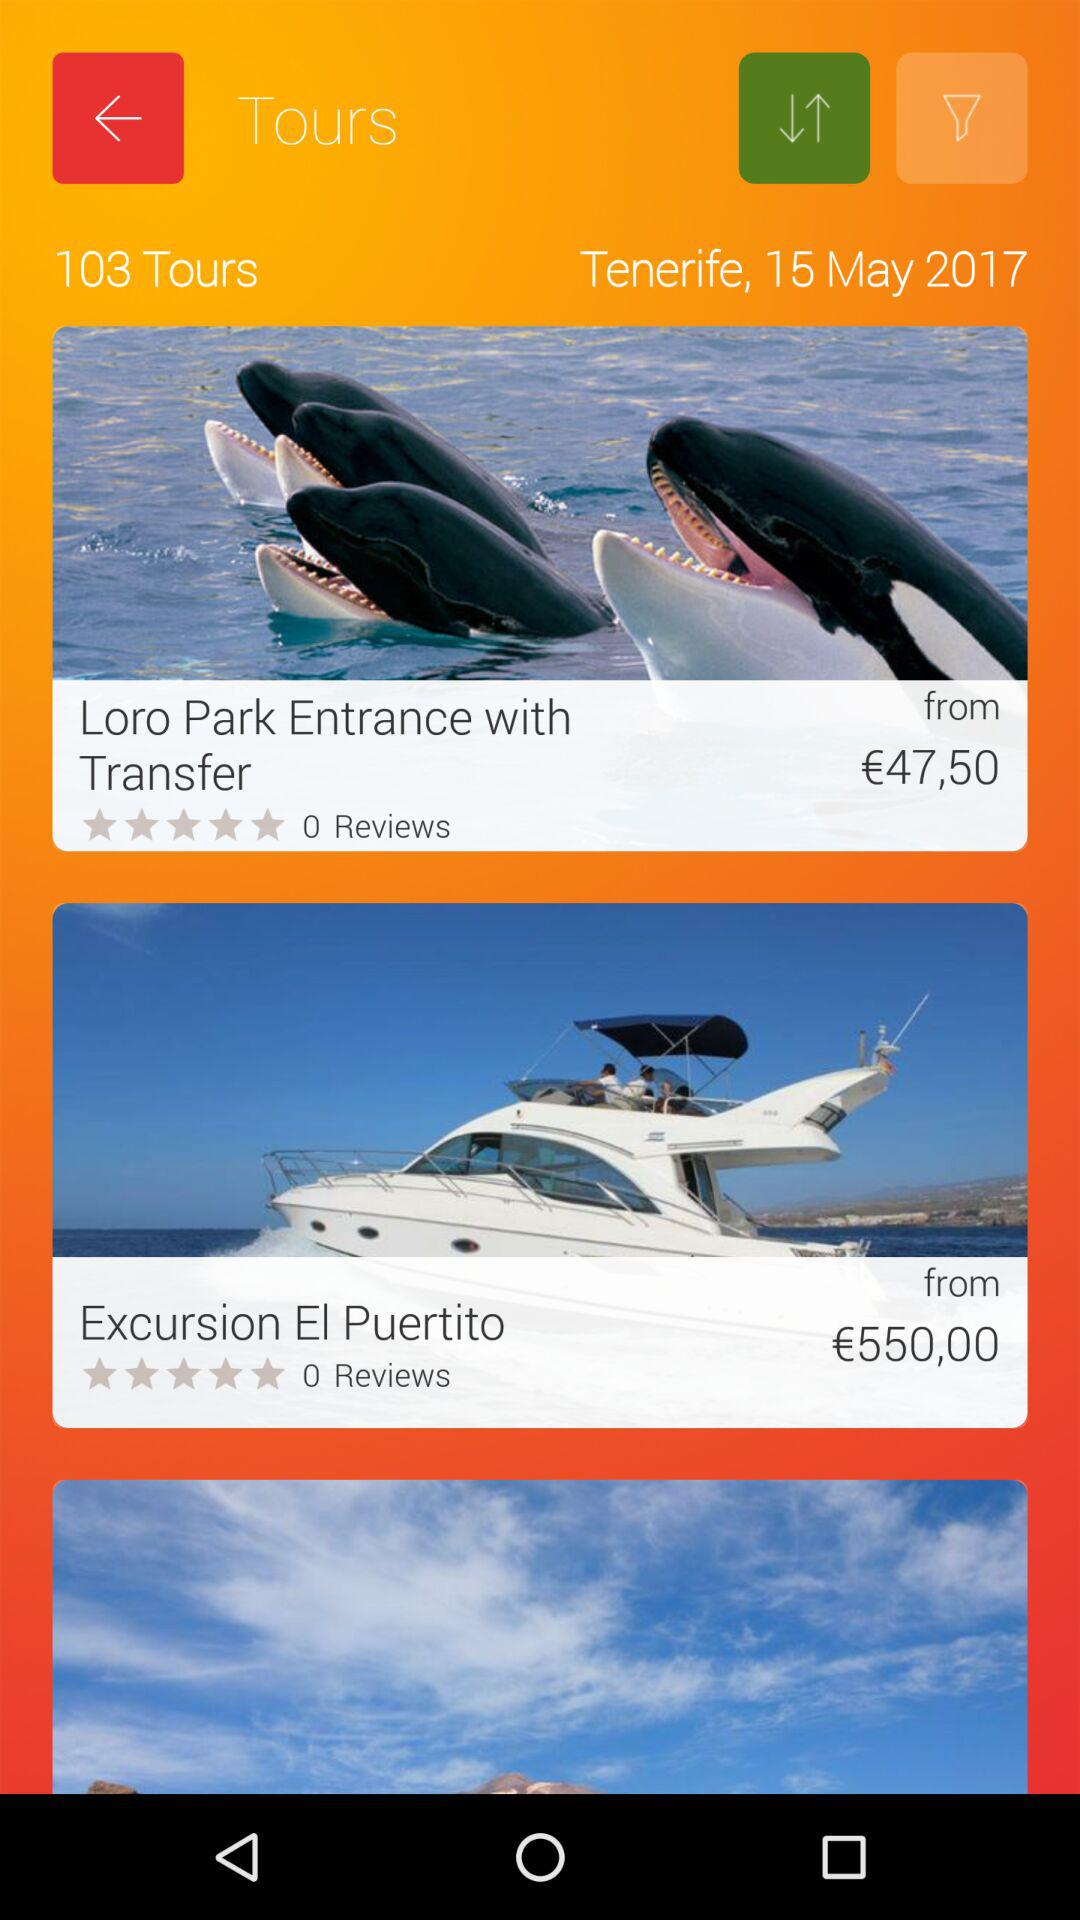What is the date? The date is May 15, 2017. 